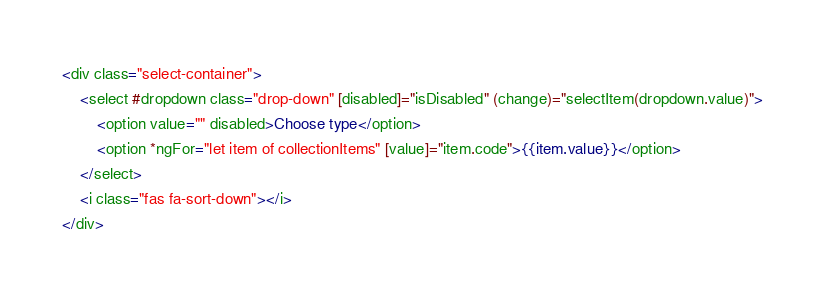<code> <loc_0><loc_0><loc_500><loc_500><_HTML_><div class="select-container">
    <select #dropdown class="drop-down" [disabled]="isDisabled" (change)="selectItem(dropdown.value)">
        <option value="" disabled>Choose type</option>
        <option *ngFor="let item of collectionItems" [value]="item.code">{{item.value}}</option>
    </select>
    <i class="fas fa-sort-down"></i>
</div></code> 